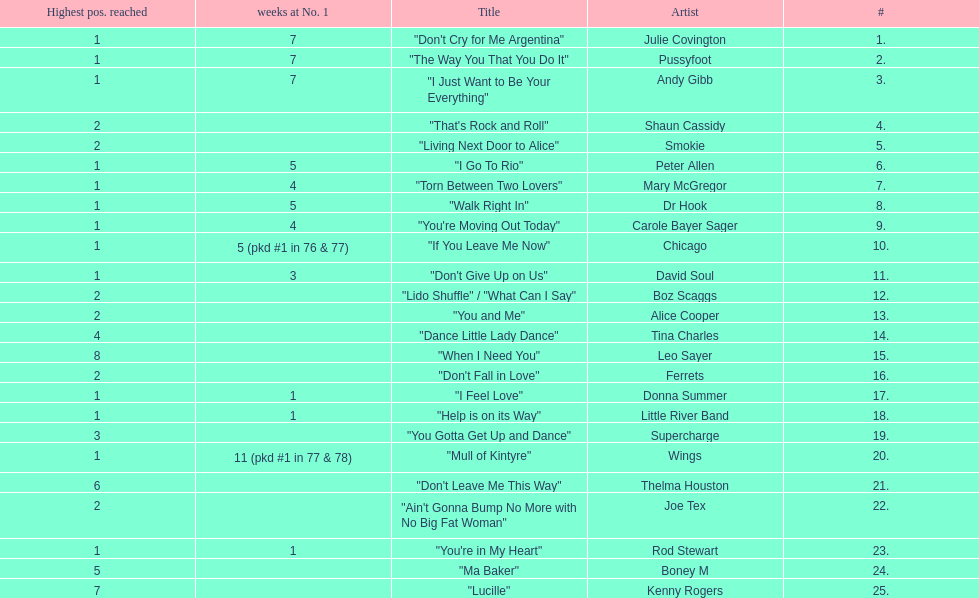Which three artists had a single at number 1 for at least 7 weeks on the australian singles charts in 1977? Julie Covington, Pussyfoot, Andy Gibb. 